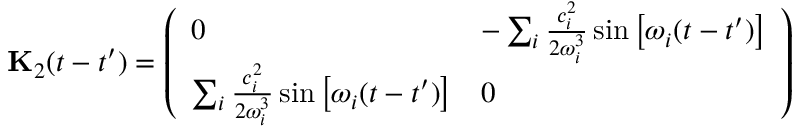<formula> <loc_0><loc_0><loc_500><loc_500>{ K } _ { 2 } ( t - t ^ { \prime } ) = \left ( \begin{array} { l l } { 0 } & { - \sum _ { i } \frac { c _ { i } ^ { 2 } } { 2 \omega _ { i } ^ { 3 } } \sin \left [ \omega _ { i } ( t - t ^ { \prime } ) \right ] } \\ { \sum _ { i } \frac { c _ { i } ^ { 2 } } { 2 \omega _ { i } ^ { 3 } } \sin \left [ \omega _ { i } ( t - t ^ { \prime } ) \right ] } & { 0 } \end{array} \right )</formula> 